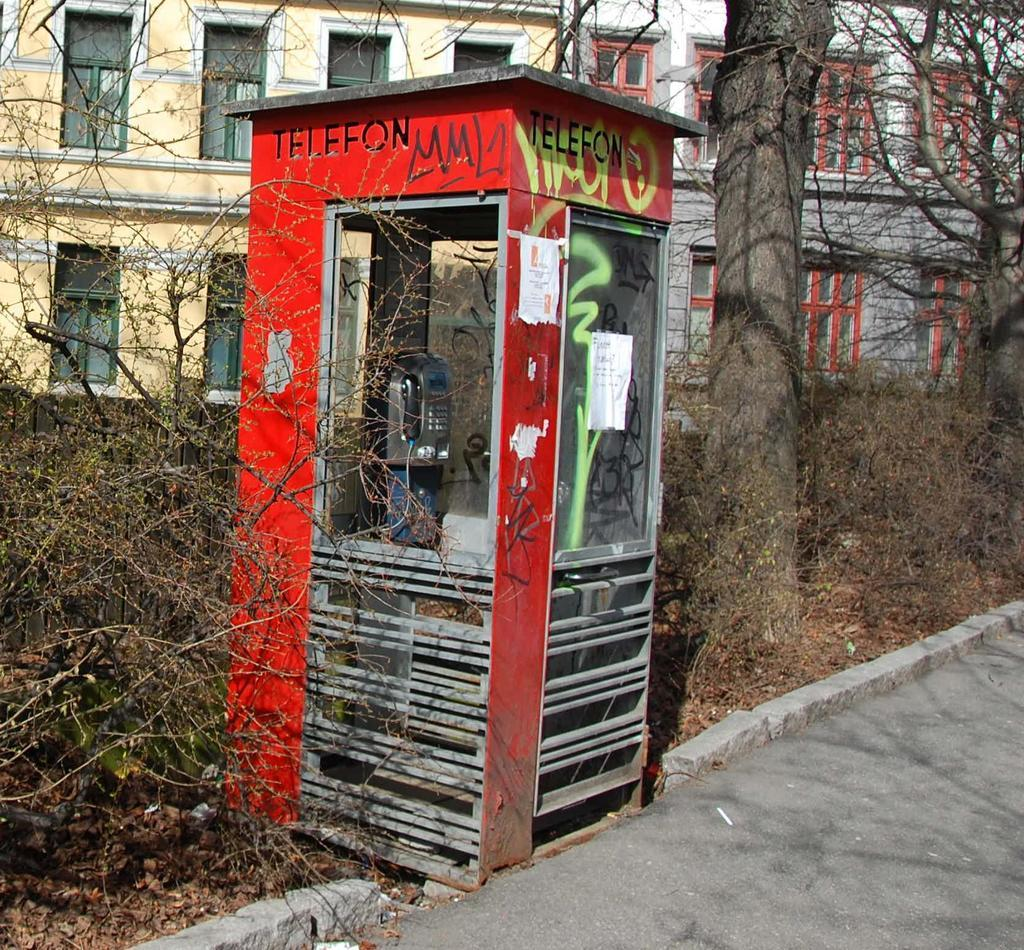What structure is present in the image? There is a telephone booth in the image. What can be found inside the telephone booth? The telephone booth contains a telephone. What type of vegetation is visible in the image? There are plants and trees in the image. What can be seen in the background of the image? There are buildings with windows in the background of the image. Where is the toad located in the image? There is no toad present in the image. What type of wood can be seen in the image? There is no wood visible in the image; it features a telephone booth, plants, trees, and buildings. 